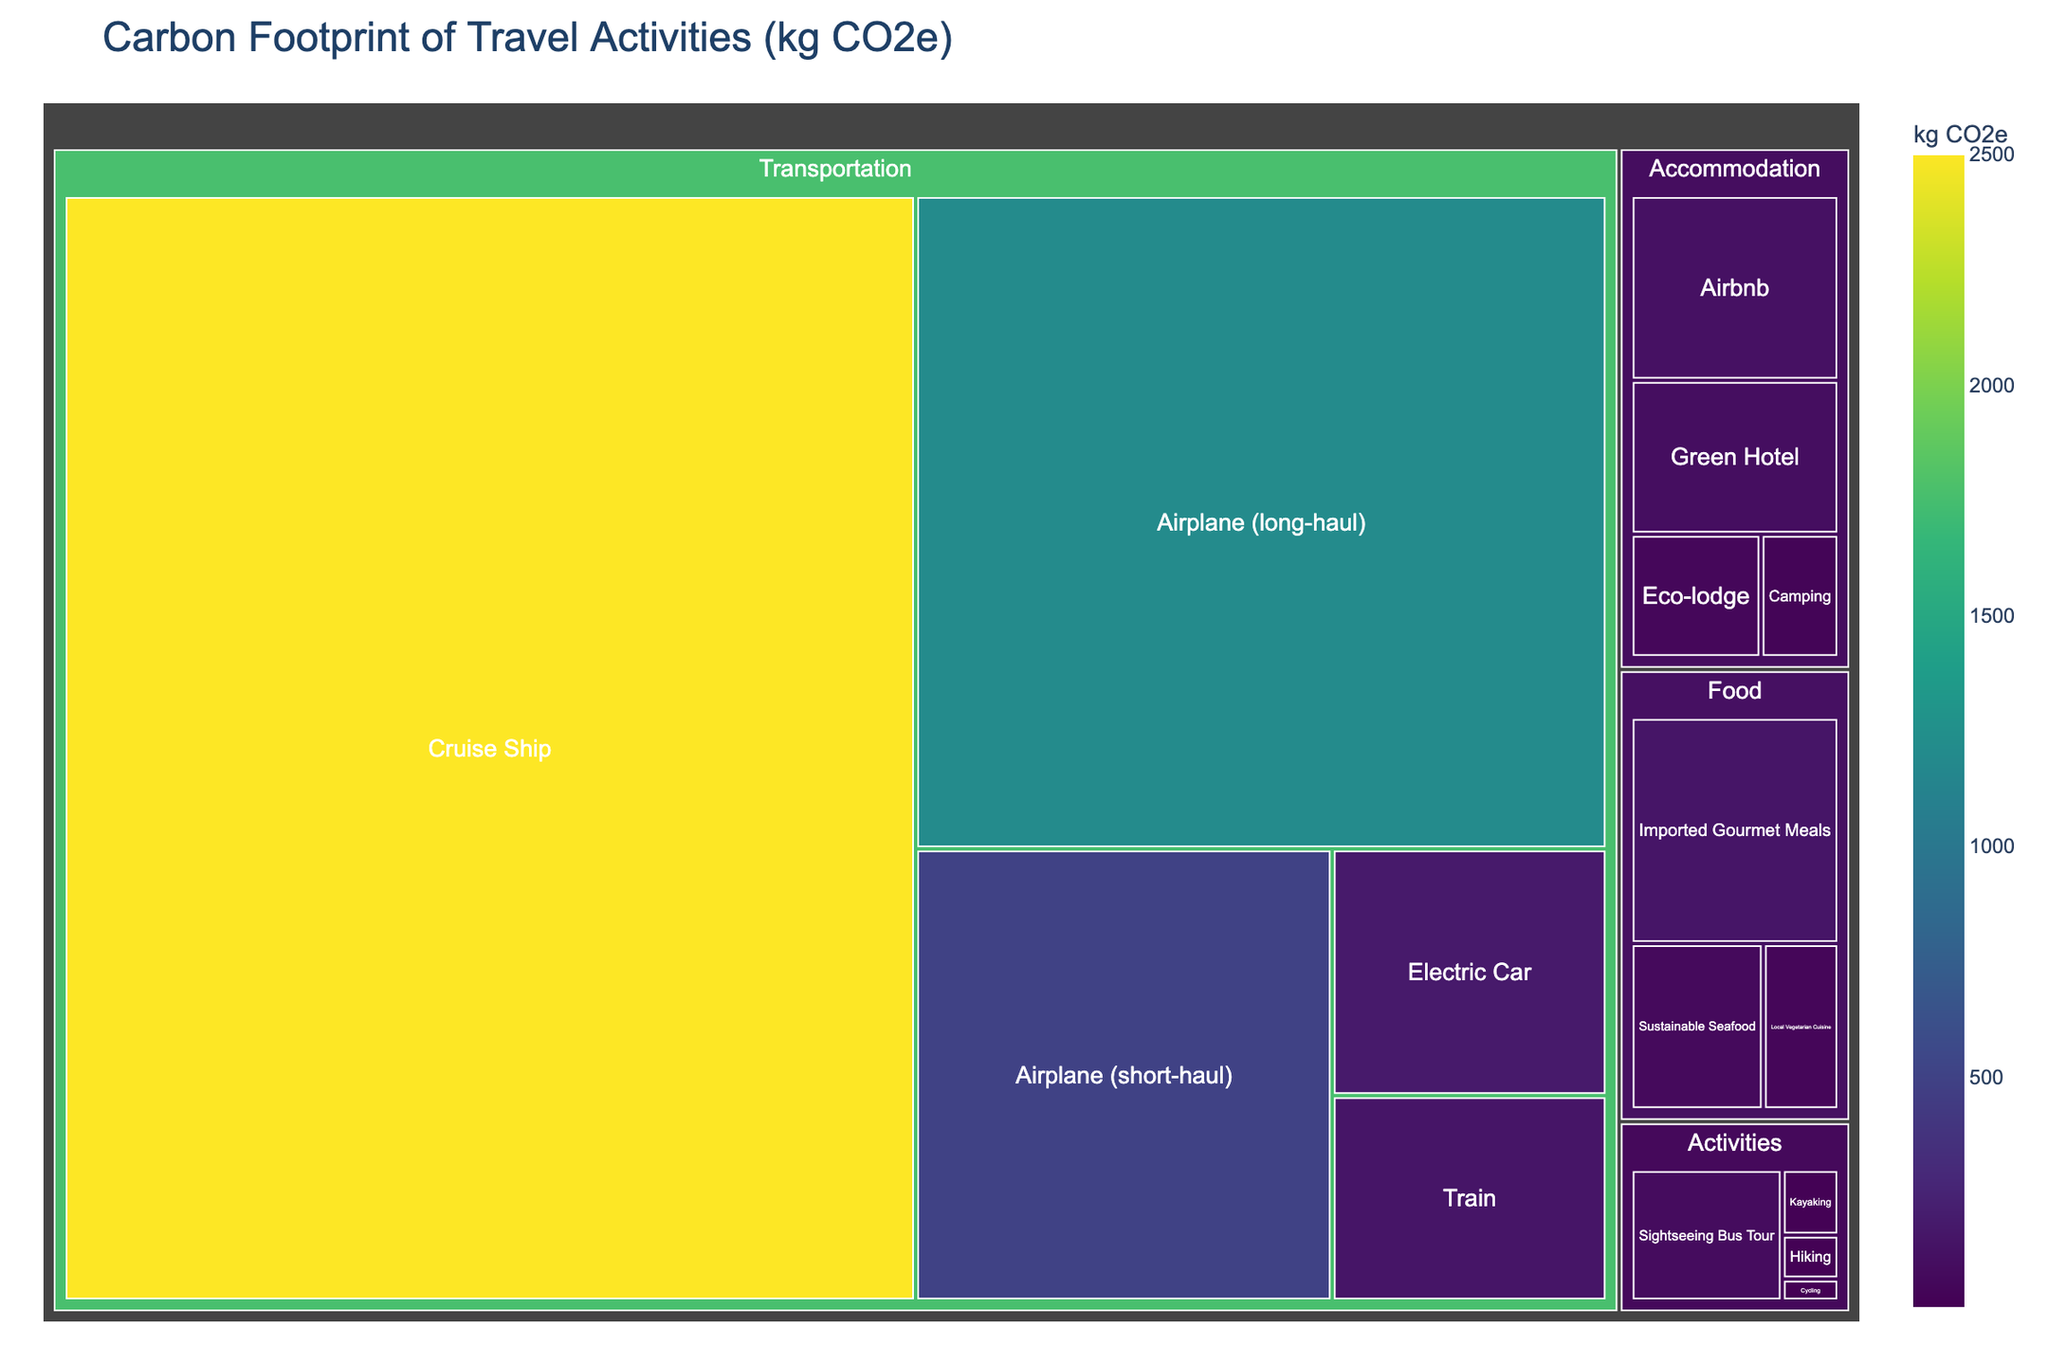Which activity category has the lowest carbon footprint? The treemap categorizes activities into Transportation, Accommodation, Activities, and Food. The smallest sections, indicating the lowest carbon footprints, are found in the Activities category.
Answer: Activities Which subcategory in Transportation has the highest carbon footprint? In the treemap under the Transportation category, the largest section, which indicates the highest carbon footprint, is labeled as 'Airplane (long-haul)'.
Answer: Airplane (long-haul) What is the combined carbon footprint of Camping and Hiking? Identify the carbon footprint values for Camping (30 kg CO2e) and Hiking (10 kg CO2e) from the Accommodation and Activities categories respectively. Add these values together: 30 + 10.
Answer: 40 kg CO2e Which has a greater carbon footprint: Train travel or staying at a Green Hotel? Compare the values for Train (150 kg CO2e) in Transportation and Green Hotel (100 kg CO2e) in Accommodation. Train travel has a higher value.
Answer: Train travel How does the carbon footprint of a Cruise Ship compare to that of Airplane (long-haul)? Look at the values for Cruise Ship (2500 kg CO2e) and Airplane (long-haul) (1200 kg CO2e) in the Transportation category. The Cruise Ship has a significantly higher value.
Answer: Cruise Ship What is the total carbon footprint of all Food activities? Sum the values of Local Vegetarian Cuisine (40 kg CO2e), Imported Gourmet Meals (150 kg CO2e), and Sustainable Seafood (70 kg CO2e) from the Food category. Total is 40 + 150 + 70.
Answer: 260 kg CO2e Which subcategory in Accommodation has the lowest carbon footprint? Among the Accommodation subcategories, the smallest area, representing the lowest carbon footprint, is 'Camping' with 30 kg CO2e.
Answer: Camping Between Eco-lodge and Airbnb, which one has a higher carbon footprint and by how much? Compare the Eco-lodge (50 kg CO2e) and Airbnb (120 kg CO2e) values. Subtract the smaller value from the larger one: 120 - 50.
Answer: Airbnb by 70 kg CO2e What is the average carbon footprint of the Activities subcategories? Calculate the sum of the values for Hiking (10 kg CO2e), Cycling (5 kg CO2e), Kayaking (15 kg CO2e), and Sightseeing Bus Tour (80 kg CO2e). Then, divide by the number of subcategories: (10 + 5 + 15 + 80) / 4.
Answer: 27.5 kg CO2e Which travel activity within the Food category has the highest carbon footprint? Among the Food subcategories, the largest section indicating the highest carbon footprint is 'Imported Gourmet Meals' with 150 kg CO2e.
Answer: Imported Gourmet Meals 